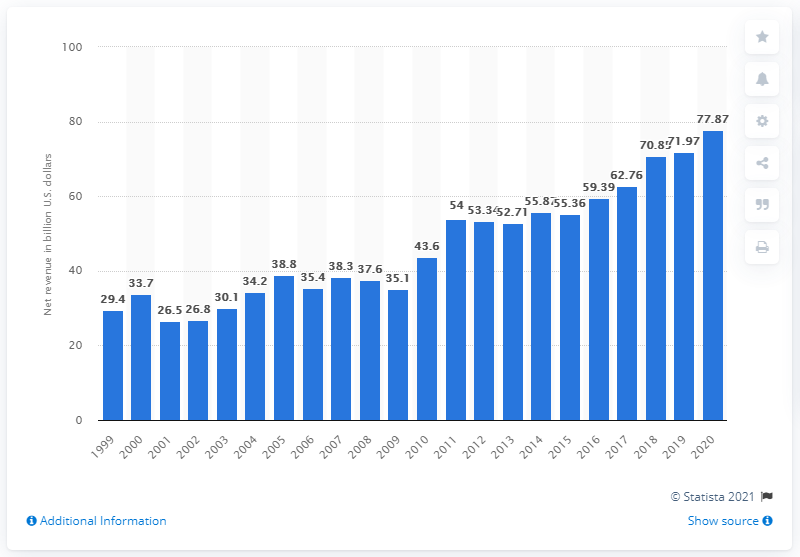Specify some key components in this picture. In 2020, Intel's revenue was 77.87. Intel's revenue in the prior year was 71.97. 